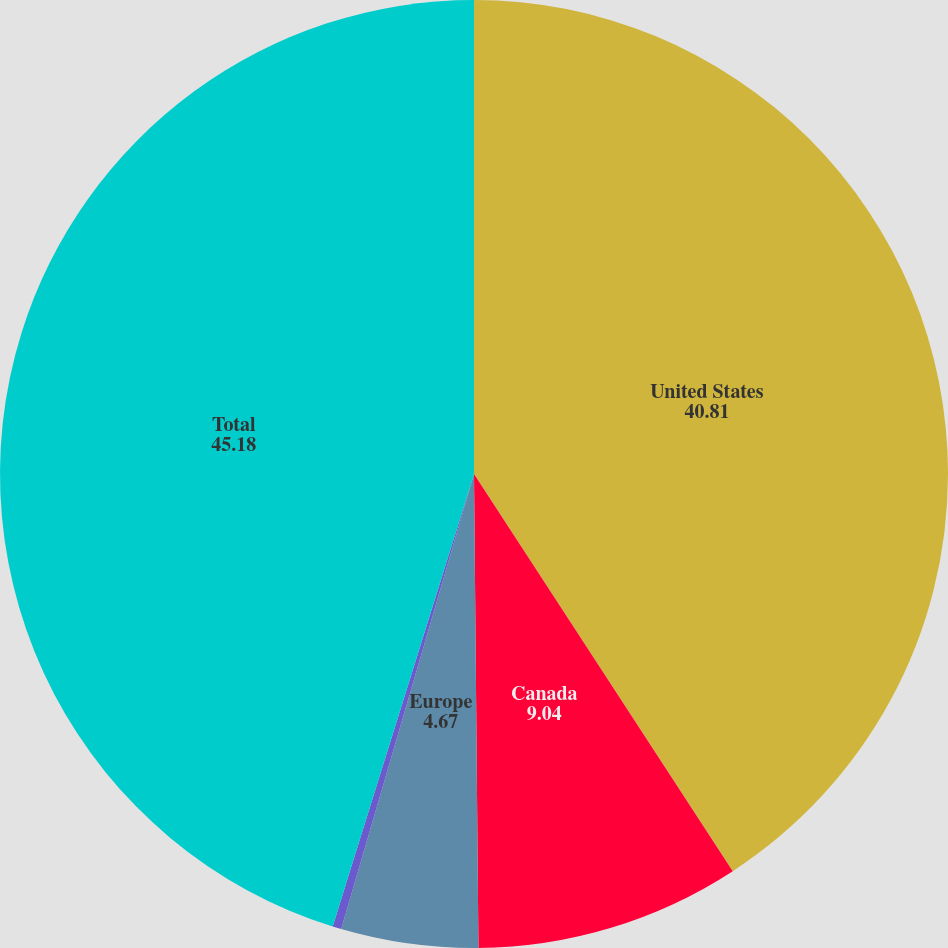<chart> <loc_0><loc_0><loc_500><loc_500><pie_chart><fcel>United States<fcel>Canada<fcel>Europe<fcel>Other<fcel>Total<nl><fcel>40.81%<fcel>9.04%<fcel>4.67%<fcel>0.3%<fcel>45.18%<nl></chart> 